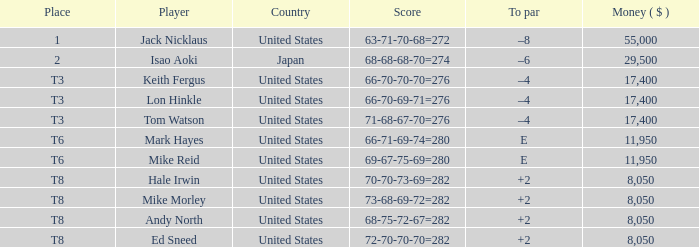Where in the united states is a golf course with a player called hale irwin? 2.0. 